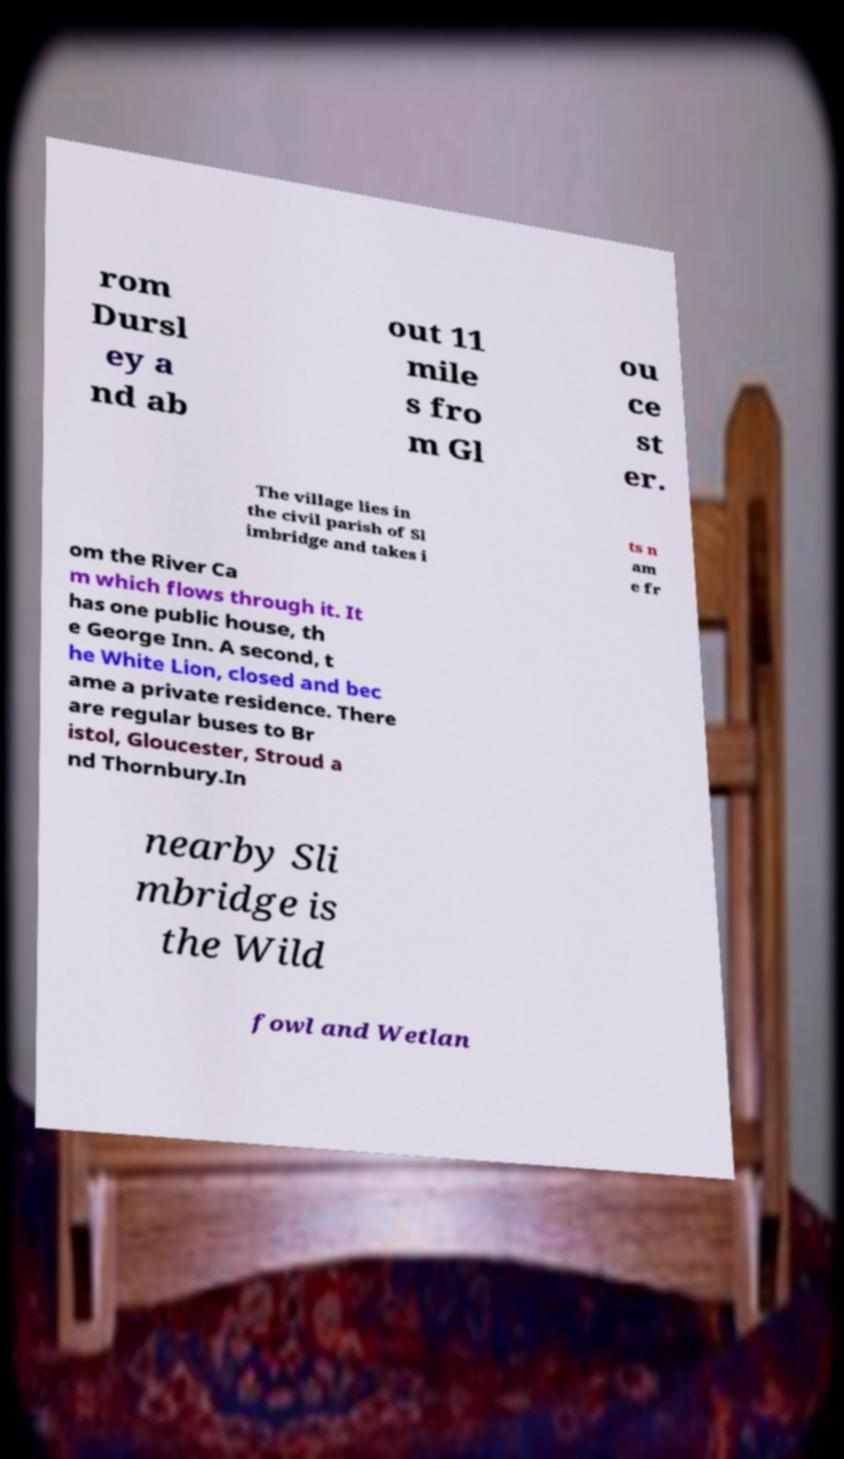What messages or text are displayed in this image? I need them in a readable, typed format. rom Dursl ey a nd ab out 11 mile s fro m Gl ou ce st er. The village lies in the civil parish of Sl imbridge and takes i ts n am e fr om the River Ca m which flows through it. It has one public house, th e George Inn. A second, t he White Lion, closed and bec ame a private residence. There are regular buses to Br istol, Gloucester, Stroud a nd Thornbury.In nearby Sli mbridge is the Wild fowl and Wetlan 